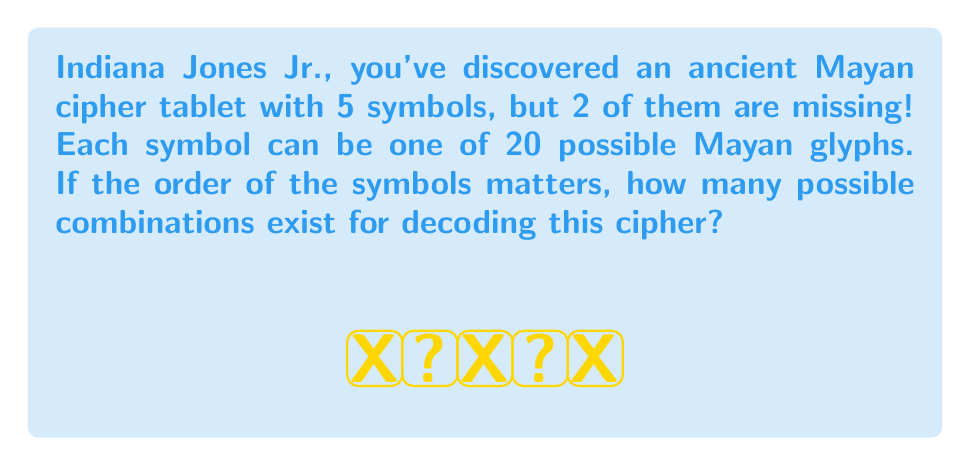Can you answer this question? Let's approach this step-by-step, young adventurer!

1) We have 5 positions in total, and 2 of them are missing.

2) For the 3 known symbols, we don't need to consider any combinations as they are fixed.

3) For each of the 2 missing symbols, we have 20 possible Mayan glyphs to choose from.

4) This is a perfect scenario for using the multiplication principle of counting.

5) For the first missing symbol, we have 20 choices.

6) For the second missing symbol, we again have 20 choices, regardless of what we chose for the first symbol.

7) Therefore, the total number of possible combinations is:

   $$ 20 \times 20 = 400 $$

8) We can also express this using exponentiation:

   $$ 20^2 = 400 $$

This is because we're making 2 independent choices, each with 20 options.
Answer: $400$ 